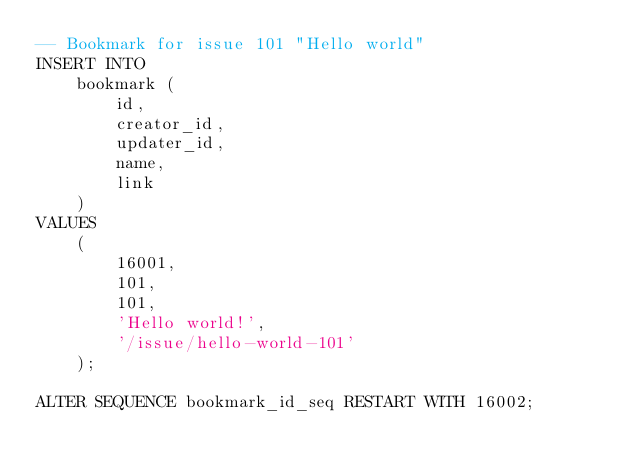Convert code to text. <code><loc_0><loc_0><loc_500><loc_500><_SQL_>-- Bookmark for issue 101 "Hello world"
INSERT INTO
    bookmark (
        id,
        creator_id,
        updater_id,
        name,
        link
    )
VALUES
    (
        16001,
        101,
        101,
        'Hello world!',
        '/issue/hello-world-101'
    );

ALTER SEQUENCE bookmark_id_seq RESTART WITH 16002;
</code> 